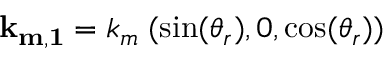Convert formula to latex. <formula><loc_0><loc_0><loc_500><loc_500>{ k _ { m , 1 } } = k _ { m } \, ( \sin ( \theta _ { r } ) , 0 , \cos ( \theta _ { r } ) )</formula> 